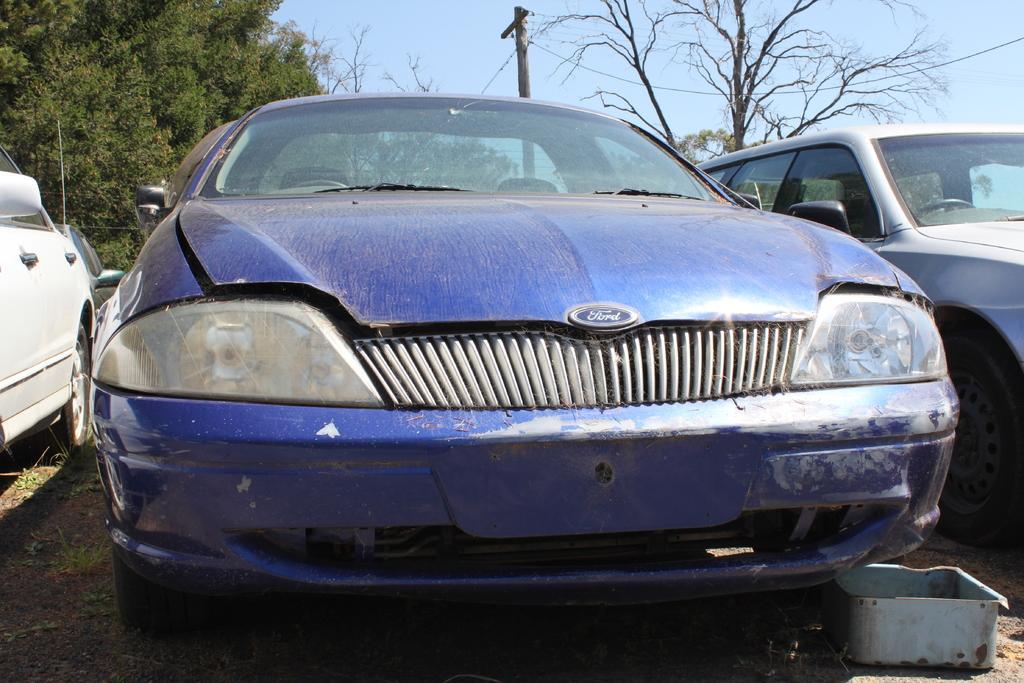Please provide a concise description of this image. As we can see in the image there are different colors of cars, current pole, trees and sky. 